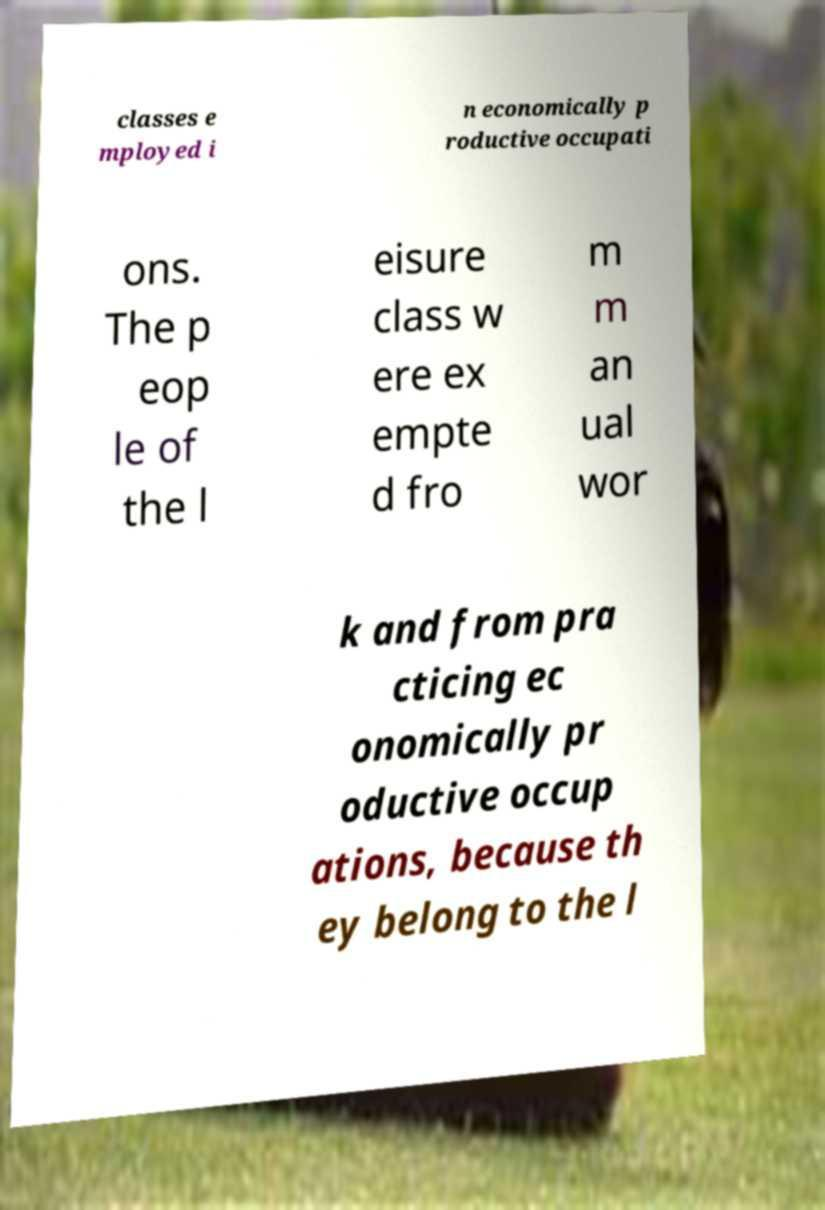Could you extract and type out the text from this image? classes e mployed i n economically p roductive occupati ons. The p eop le of the l eisure class w ere ex empte d fro m m an ual wor k and from pra cticing ec onomically pr oductive occup ations, because th ey belong to the l 